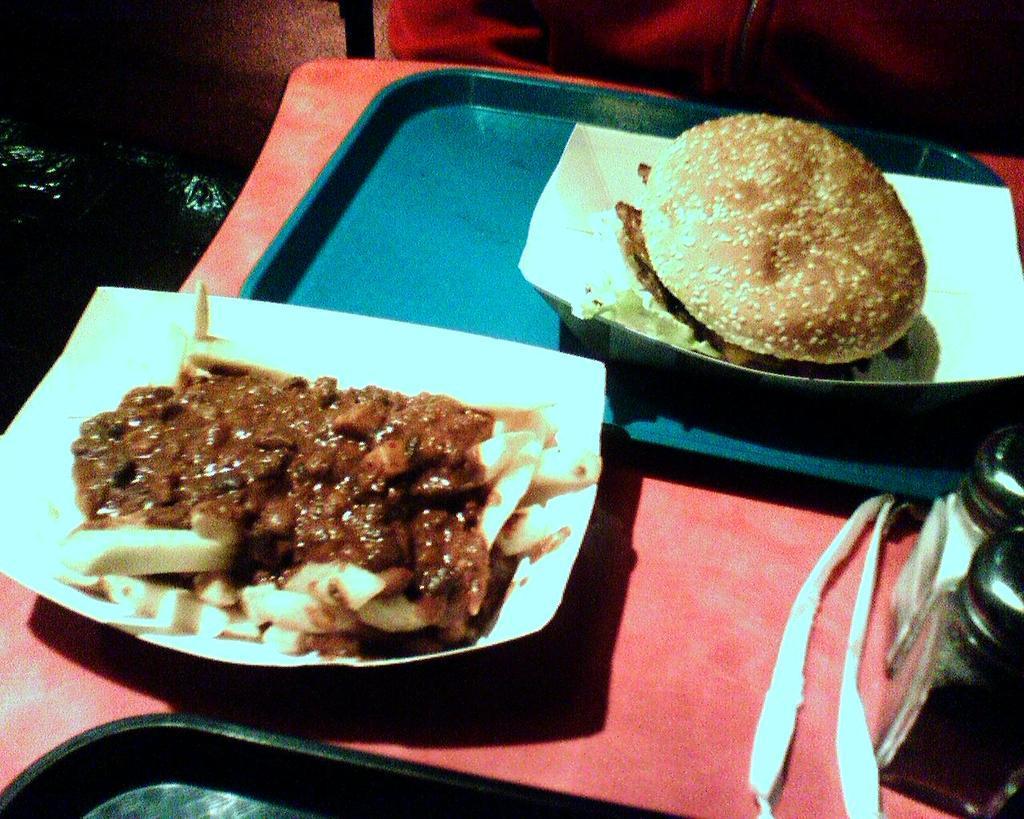How would you summarize this image in a sentence or two? In the center of the image we can see a table. On the table we can see the trays, bottles and the plates which contains food. In the background of the image we can see the wall. At the top of the image we can see a person, wearing coat. 